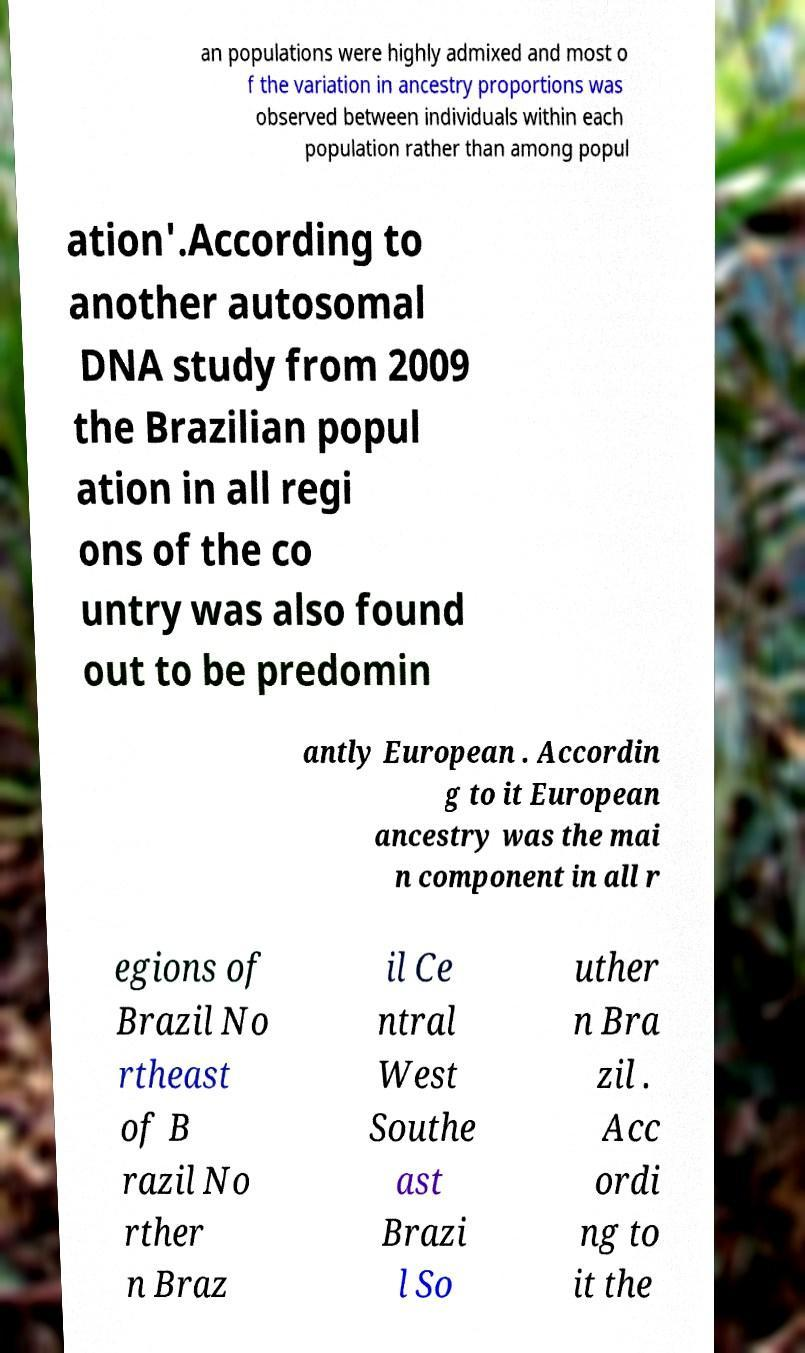Could you extract and type out the text from this image? an populations were highly admixed and most o f the variation in ancestry proportions was observed between individuals within each population rather than among popul ation'.According to another autosomal DNA study from 2009 the Brazilian popul ation in all regi ons of the co untry was also found out to be predomin antly European . Accordin g to it European ancestry was the mai n component in all r egions of Brazil No rtheast of B razil No rther n Braz il Ce ntral West Southe ast Brazi l So uther n Bra zil . Acc ordi ng to it the 